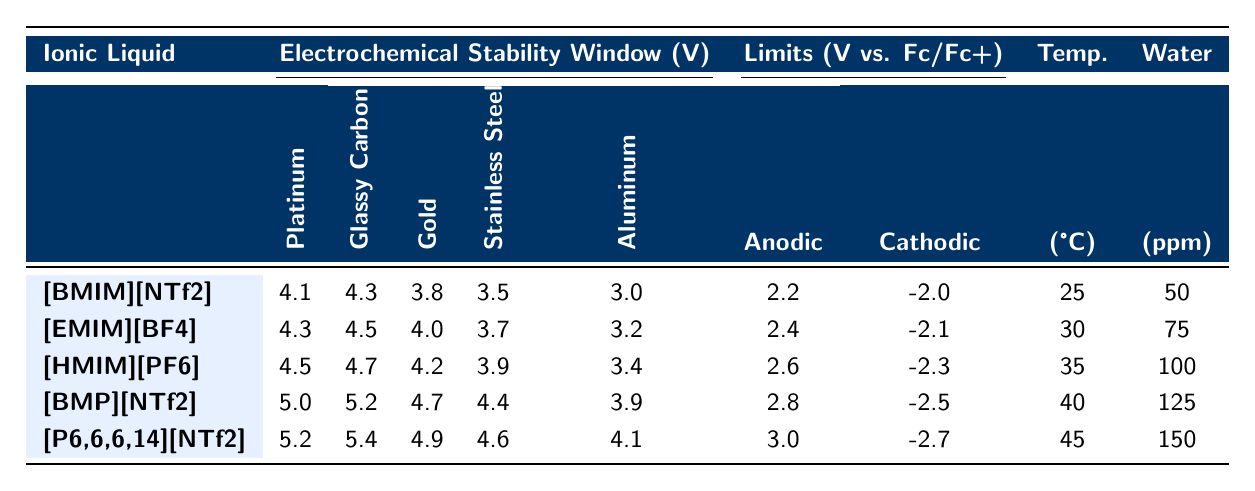What is the electrochemical stability window for [BMIM][NTf2] using a Platinum electrode? The table shows that the electrochemical stability window for [BMIM][NTf2] at a Platinum electrode is 4.1 V.
Answer: 4.1 V What is the anodic limit for the ionic liquid [HMIM][PF6]? According to the table, the anodic limit for [HMIM][PF6] is 2.6 V vs. Fc/Fc+.
Answer: 2.6 V vs. Fc/Fc+ Which ionic liquid has the highest cathodic limit and what is its value? The table indicates that [P6,6,6,14][NTf2] has the highest cathodic limit of -2.7 V vs. Fc/Fc+.
Answer: -2.7 V vs. Fc/Fc+ What is the temperature at which [BMP][NTf2] was measured? The table states that [BMP][NTf2] was measured at a temperature of 40 °C.
Answer: 40 °C What is the difference in electrochemical stability window between the Platinum and Glassy Carbon electrodes for [EMIM][BF4]? For [EMIM][BF4], the stability window for Platinum is 4.3 V and for Glassy Carbon is 4.5 V. The difference is 4.5 V - 4.3 V = 0.2 V.
Answer: 0.2 V What is the average anodic limit of all ionic liquids listed in the table? The anodic limits for the ionic liquids are 2.2, 2.4, 2.6, 2.8, and 3.0 V. Their sum is 2.2 + 2.4 + 2.6 + 2.8 + 3.0 = 13.0 V. The average is 13.0 V / 5 = 2.6 V.
Answer: 2.6 V For which electrode does the ionic liquid [HMIM][PF6] exhibit the highest electrochemical stability? The table indicates that for [HMIM][PF6], the highest electrochemical stability is observed with a Platinum electrode at 4.5 V.
Answer: Platinum electrode Is [P6,6,6,14][NTf2] stable at a higher cathodic limit than [EMIM][BF4]? The cathodic limit for [P6,6,6,14][NTf2] is -2.7 V, and for [EMIM][BF4] it is -2.1 V. Since -2.7 V is lower than -2.1 V, this statement is false.
Answer: No What temperature showed the highest anodic limit of 3.0 V in the table? The highest anodic limit of 3.0 V corresponds to the ionic liquid [P6,6,6,14][NTf2], which was measured at 45 °C.
Answer: 45 °C If the water content in [BMIM][NTf2] is increased to 100 ppm, how does the stability window using a Glassy Carbon electrode change? The stability window with 100 ppm water content is not directly provided for [BMIM][NTf2], but the original is 4.3 V. We cannot determine the specific change based on the available data.
Answer: Not determinable 